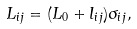Convert formula to latex. <formula><loc_0><loc_0><loc_500><loc_500>L _ { i j } = ( L _ { 0 } + l _ { i j } ) \sigma _ { i j } ,</formula> 